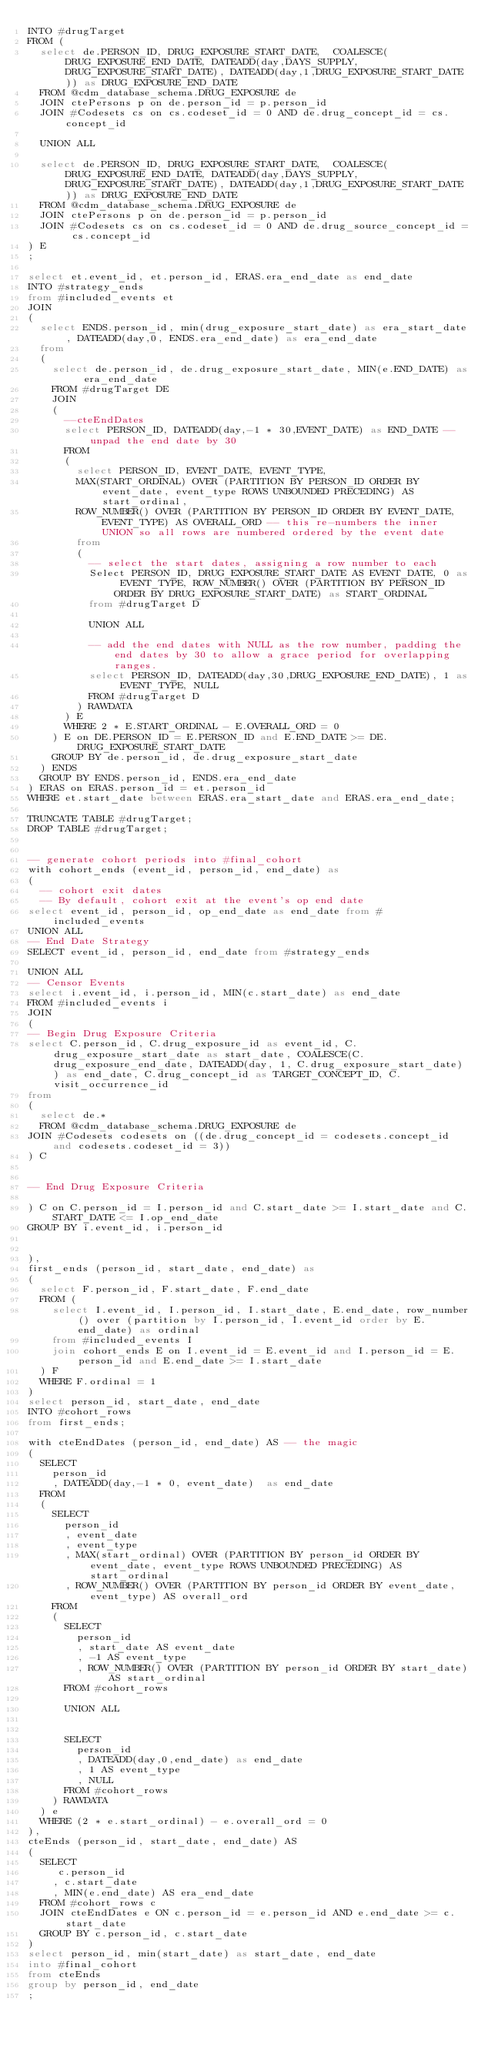Convert code to text. <code><loc_0><loc_0><loc_500><loc_500><_SQL_>INTO #drugTarget
FROM (
	select de.PERSON_ID, DRUG_EXPOSURE_START_DATE,  COALESCE(DRUG_EXPOSURE_END_DATE, DATEADD(day,DAYS_SUPPLY,DRUG_EXPOSURE_START_DATE), DATEADD(day,1,DRUG_EXPOSURE_START_DATE)) as DRUG_EXPOSURE_END_DATE 
	FROM @cdm_database_schema.DRUG_EXPOSURE de
	JOIN ctePersons p on de.person_id = p.person_id
	JOIN #Codesets cs on cs.codeset_id = 0 AND de.drug_concept_id = cs.concept_id

	UNION ALL

	select de.PERSON_ID, DRUG_EXPOSURE_START_DATE,  COALESCE(DRUG_EXPOSURE_END_DATE, DATEADD(day,DAYS_SUPPLY,DRUG_EXPOSURE_START_DATE), DATEADD(day,1,DRUG_EXPOSURE_START_DATE)) as DRUG_EXPOSURE_END_DATE 
	FROM @cdm_database_schema.DRUG_EXPOSURE de
	JOIN ctePersons p on de.person_id = p.person_id
	JOIN #Codesets cs on cs.codeset_id = 0 AND de.drug_source_concept_id = cs.concept_id
) E
;

select et.event_id, et.person_id, ERAS.era_end_date as end_date
INTO #strategy_ends
from #included_events et
JOIN 
(
  select ENDS.person_id, min(drug_exposure_start_date) as era_start_date, DATEADD(day,0, ENDS.era_end_date) as era_end_date
  from
  (
    select de.person_id, de.drug_exposure_start_date, MIN(e.END_DATE) as era_end_date
    FROM #drugTarget DE
    JOIN 
    (
      --cteEndDates
      select PERSON_ID, DATEADD(day,-1 * 30,EVENT_DATE) as END_DATE -- unpad the end date by 30
      FROM
      (
				select PERSON_ID, EVENT_DATE, EVENT_TYPE, 
				MAX(START_ORDINAL) OVER (PARTITION BY PERSON_ID ORDER BY event_date, event_type ROWS UNBOUNDED PRECEDING) AS start_ordinal,
				ROW_NUMBER() OVER (PARTITION BY PERSON_ID ORDER BY EVENT_DATE, EVENT_TYPE) AS OVERALL_ORD -- this re-numbers the inner UNION so all rows are numbered ordered by the event date
				from
				(
					-- select the start dates, assigning a row number to each
					Select PERSON_ID, DRUG_EXPOSURE_START_DATE AS EVENT_DATE, 0 as EVENT_TYPE, ROW_NUMBER() OVER (PARTITION BY PERSON_ID ORDER BY DRUG_EXPOSURE_START_DATE) as START_ORDINAL
					from #drugTarget D

					UNION ALL

					-- add the end dates with NULL as the row number, padding the end dates by 30 to allow a grace period for overlapping ranges.
					select PERSON_ID, DATEADD(day,30,DRUG_EXPOSURE_END_DATE), 1 as EVENT_TYPE, NULL
					FROM #drugTarget D
				) RAWDATA
      ) E
      WHERE 2 * E.START_ORDINAL - E.OVERALL_ORD = 0
    ) E on DE.PERSON_ID = E.PERSON_ID and E.END_DATE >= DE.DRUG_EXPOSURE_START_DATE
    GROUP BY de.person_id, de.drug_exposure_start_date
  ) ENDS
  GROUP BY ENDS.person_id, ENDS.era_end_date
) ERAS on ERAS.person_id = et.person_id 
WHERE et.start_date between ERAS.era_start_date and ERAS.era_end_date;

TRUNCATE TABLE #drugTarget;
DROP TABLE #drugTarget;


-- generate cohort periods into #final_cohort
with cohort_ends (event_id, person_id, end_date) as
(
	-- cohort exit dates
  -- By default, cohort exit at the event's op end date
select event_id, person_id, op_end_date as end_date from #included_events
UNION ALL
-- End Date Strategy
SELECT event_id, person_id, end_date from #strategy_ends

UNION ALL
-- Censor Events
select i.event_id, i.person_id, MIN(c.start_date) as end_date
FROM #included_events i
JOIN
(
-- Begin Drug Exposure Criteria
select C.person_id, C.drug_exposure_id as event_id, C.drug_exposure_start_date as start_date, COALESCE(C.drug_exposure_end_date, DATEADD(day, 1, C.drug_exposure_start_date)) as end_date, C.drug_concept_id as TARGET_CONCEPT_ID, C.visit_occurrence_id
from 
(
  select de.* 
  FROM @cdm_database_schema.DRUG_EXPOSURE de
JOIN #Codesets codesets on ((de.drug_concept_id = codesets.concept_id and codesets.codeset_id = 3))
) C


-- End Drug Exposure Criteria

) C on C.person_id = I.person_id and C.start_date >= I.start_date and C.START_DATE <= I.op_end_date
GROUP BY i.event_id, i.person_id


),
first_ends (person_id, start_date, end_date) as
(
	select F.person_id, F.start_date, F.end_date
	FROM (
	  select I.event_id, I.person_id, I.start_date, E.end_date, row_number() over (partition by I.person_id, I.event_id order by E.end_date) as ordinal 
	  from #included_events I
	  join cohort_ends E on I.event_id = E.event_id and I.person_id = E.person_id and E.end_date >= I.start_date
	) F
	WHERE F.ordinal = 1
)
select person_id, start_date, end_date
INTO #cohort_rows
from first_ends;

with cteEndDates (person_id, end_date) AS -- the magic
(	
	SELECT
		person_id
		, DATEADD(day,-1 * 0, event_date)  as end_date
	FROM
	(
		SELECT
			person_id
			, event_date
			, event_type
			, MAX(start_ordinal) OVER (PARTITION BY person_id ORDER BY event_date, event_type ROWS UNBOUNDED PRECEDING) AS start_ordinal 
			, ROW_NUMBER() OVER (PARTITION BY person_id ORDER BY event_date, event_type) AS overall_ord
		FROM
		(
			SELECT
				person_id
				, start_date AS event_date
				, -1 AS event_type
				, ROW_NUMBER() OVER (PARTITION BY person_id ORDER BY start_date) AS start_ordinal
			FROM #cohort_rows
		
			UNION ALL
		

			SELECT
				person_id
				, DATEADD(day,0,end_date) as end_date
				, 1 AS event_type
				, NULL
			FROM #cohort_rows
		) RAWDATA
	) e
	WHERE (2 * e.start_ordinal) - e.overall_ord = 0
),
cteEnds (person_id, start_date, end_date) AS
(
	SELECT
		 c.person_id
		, c.start_date
		, MIN(e.end_date) AS era_end_date
	FROM #cohort_rows c
	JOIN cteEndDates e ON c.person_id = e.person_id AND e.end_date >= c.start_date
	GROUP BY c.person_id, c.start_date
)
select person_id, min(start_date) as start_date, end_date
into #final_cohort
from cteEnds
group by person_id, end_date
;
</code> 